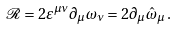Convert formula to latex. <formula><loc_0><loc_0><loc_500><loc_500>\mathcal { R } = 2 \varepsilon ^ { \mu \nu } \partial _ { \mu } \omega _ { \nu } = 2 \partial _ { \mu } \hat { \omega } _ { \mu } \, .</formula> 